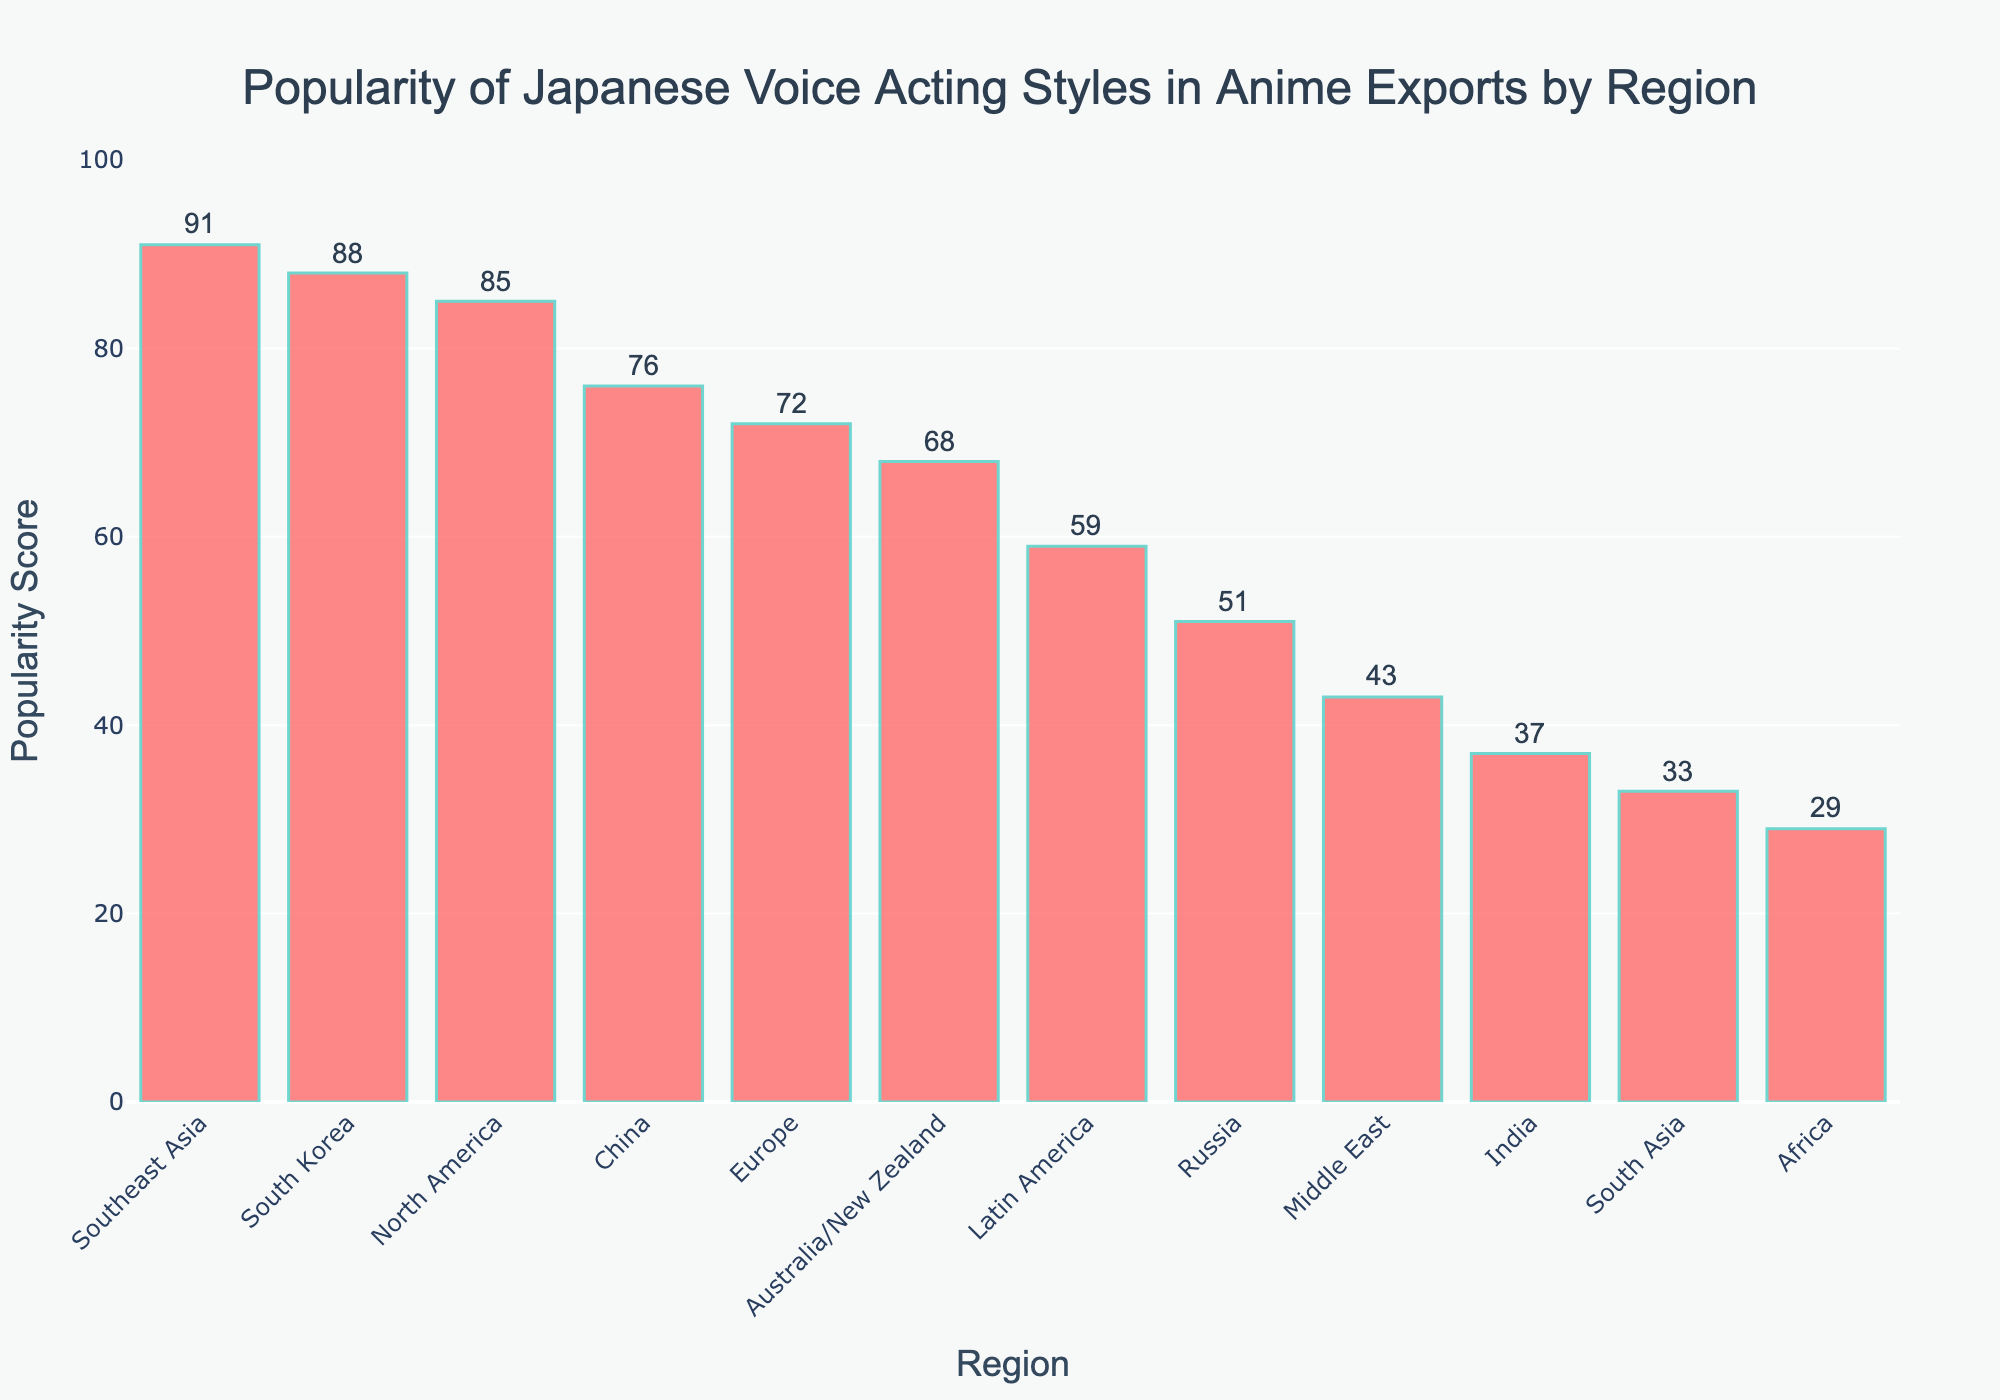Which region has the highest popularity score? Based on the bar chart, Southeast Asia has the tallest bar which indicates the highest popularity score of 91.
Answer: Southeast Asia Which region has the lowest popularity score? From the figure, Africa shows the shortest bar, representing the lowest popularity score of 29.
Answer: Africa Between North America and South Korea, which region shows a higher popularity score? By comparing the heights of the bars for North America and South Korea, North America's bar is slightly shorter than South Korea's. Therefore, South Korea has a higher popularity score of 88 compared to North America's 85.
Answer: South Korea What is the average popularity score of the regions shown in the bar chart? Sum all the popularity scores: 85+72+91+68+59+43+88+76+51+37+29+33 = 732. There are 12 regions, so divide the total by 12, giving an average of 732/12 = 61.
Answer: 61 How much more popular is Japanese voice acting in Europe compared to Australia/New Zealand? Subtract the popularity score of Australia/New Zealand from that of Europe: 72 - 68 = 4.
Answer: 4 Which regions have a popularity score greater than 80? Looking at the figure, only North America (85), Southeast Asia (91), and South Korea (88) have popularity scores greater than 80.
Answer: North America, Southeast Asia, South Korea What is the combined popularity score of China and Russia? Add the popularity scores for China and Russia: 76 + 51 = 127.
Answer: 127 How does the popularity score for Latin America compare to the median popularity score of all regions? First, list all scores in ascending order: 29, 33, 37, 43, 51, 59, 68, 72, 76, 85, 88, 91. The median score (middle value of sorted list) is the average of the 6th and 7th values: 59 and 68, so the median is (59+68)/2 = 63.5. Latin America's score (59) is lower than the median (63.5).
Answer: Lower By how much does the score of North America exceed that of Latin America? Subtract the popularity score of Latin America from North America's: 85 - 59 = 26.
Answer: 26 What is the visual difference between the regions with the highest and lowest scores? The tallest bar is for Southeast Asia with a score of 91, and the shortest bar is for Africa with a score of 29. Visually, the height difference between the bars indicates a numerical difference of 91 - 29 = 62.
Answer: 62 